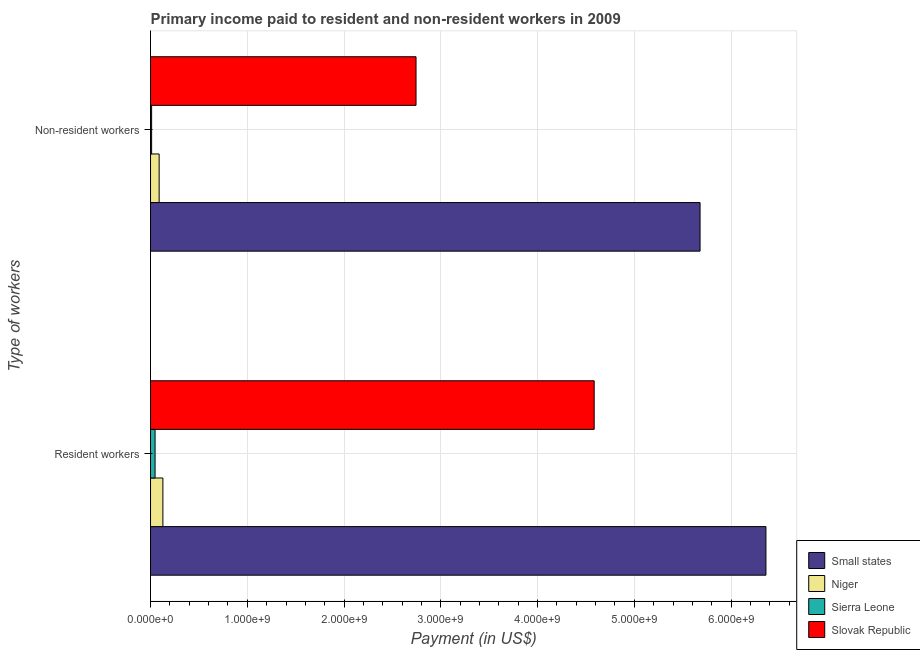Are the number of bars per tick equal to the number of legend labels?
Your answer should be compact. Yes. What is the label of the 1st group of bars from the top?
Keep it short and to the point. Non-resident workers. What is the payment made to resident workers in Slovak Republic?
Your answer should be compact. 4.59e+09. Across all countries, what is the maximum payment made to non-resident workers?
Provide a succinct answer. 5.68e+09. Across all countries, what is the minimum payment made to non-resident workers?
Your answer should be very brief. 1.13e+07. In which country was the payment made to resident workers maximum?
Provide a short and direct response. Small states. In which country was the payment made to resident workers minimum?
Provide a succinct answer. Sierra Leone. What is the total payment made to non-resident workers in the graph?
Offer a very short reply. 8.52e+09. What is the difference between the payment made to non-resident workers in Slovak Republic and that in Niger?
Ensure brevity in your answer.  2.65e+09. What is the difference between the payment made to resident workers in Niger and the payment made to non-resident workers in Small states?
Give a very brief answer. -5.55e+09. What is the average payment made to resident workers per country?
Provide a succinct answer. 2.78e+09. What is the difference between the payment made to resident workers and payment made to non-resident workers in Niger?
Your answer should be compact. 3.88e+07. What is the ratio of the payment made to non-resident workers in Niger to that in Slovak Republic?
Offer a terse response. 0.03. In how many countries, is the payment made to resident workers greater than the average payment made to resident workers taken over all countries?
Provide a short and direct response. 2. What does the 3rd bar from the top in Resident workers represents?
Your answer should be compact. Niger. What does the 3rd bar from the bottom in Resident workers represents?
Give a very brief answer. Sierra Leone. How many bars are there?
Give a very brief answer. 8. How many countries are there in the graph?
Your answer should be compact. 4. What is the difference between two consecutive major ticks on the X-axis?
Give a very brief answer. 1.00e+09. Does the graph contain any zero values?
Keep it short and to the point. No. How many legend labels are there?
Ensure brevity in your answer.  4. How are the legend labels stacked?
Keep it short and to the point. Vertical. What is the title of the graph?
Your answer should be compact. Primary income paid to resident and non-resident workers in 2009. Does "Lower middle income" appear as one of the legend labels in the graph?
Keep it short and to the point. No. What is the label or title of the X-axis?
Provide a short and direct response. Payment (in US$). What is the label or title of the Y-axis?
Offer a terse response. Type of workers. What is the Payment (in US$) in Small states in Resident workers?
Make the answer very short. 6.36e+09. What is the Payment (in US$) of Niger in Resident workers?
Offer a terse response. 1.28e+08. What is the Payment (in US$) of Sierra Leone in Resident workers?
Make the answer very short. 4.69e+07. What is the Payment (in US$) in Slovak Republic in Resident workers?
Make the answer very short. 4.59e+09. What is the Payment (in US$) of Small states in Non-resident workers?
Your response must be concise. 5.68e+09. What is the Payment (in US$) of Niger in Non-resident workers?
Make the answer very short. 8.89e+07. What is the Payment (in US$) in Sierra Leone in Non-resident workers?
Ensure brevity in your answer.  1.13e+07. What is the Payment (in US$) of Slovak Republic in Non-resident workers?
Keep it short and to the point. 2.74e+09. Across all Type of workers, what is the maximum Payment (in US$) of Small states?
Keep it short and to the point. 6.36e+09. Across all Type of workers, what is the maximum Payment (in US$) in Niger?
Your response must be concise. 1.28e+08. Across all Type of workers, what is the maximum Payment (in US$) of Sierra Leone?
Your response must be concise. 4.69e+07. Across all Type of workers, what is the maximum Payment (in US$) in Slovak Republic?
Your response must be concise. 4.59e+09. Across all Type of workers, what is the minimum Payment (in US$) in Small states?
Provide a short and direct response. 5.68e+09. Across all Type of workers, what is the minimum Payment (in US$) in Niger?
Make the answer very short. 8.89e+07. Across all Type of workers, what is the minimum Payment (in US$) in Sierra Leone?
Your response must be concise. 1.13e+07. Across all Type of workers, what is the minimum Payment (in US$) in Slovak Republic?
Your response must be concise. 2.74e+09. What is the total Payment (in US$) in Small states in the graph?
Your answer should be very brief. 1.20e+1. What is the total Payment (in US$) in Niger in the graph?
Provide a succinct answer. 2.17e+08. What is the total Payment (in US$) in Sierra Leone in the graph?
Provide a short and direct response. 5.82e+07. What is the total Payment (in US$) in Slovak Republic in the graph?
Give a very brief answer. 7.33e+09. What is the difference between the Payment (in US$) of Small states in Resident workers and that in Non-resident workers?
Make the answer very short. 6.81e+08. What is the difference between the Payment (in US$) in Niger in Resident workers and that in Non-resident workers?
Ensure brevity in your answer.  3.88e+07. What is the difference between the Payment (in US$) in Sierra Leone in Resident workers and that in Non-resident workers?
Your answer should be very brief. 3.57e+07. What is the difference between the Payment (in US$) of Slovak Republic in Resident workers and that in Non-resident workers?
Provide a succinct answer. 1.84e+09. What is the difference between the Payment (in US$) of Small states in Resident workers and the Payment (in US$) of Niger in Non-resident workers?
Provide a succinct answer. 6.27e+09. What is the difference between the Payment (in US$) of Small states in Resident workers and the Payment (in US$) of Sierra Leone in Non-resident workers?
Your response must be concise. 6.35e+09. What is the difference between the Payment (in US$) in Small states in Resident workers and the Payment (in US$) in Slovak Republic in Non-resident workers?
Your answer should be very brief. 3.62e+09. What is the difference between the Payment (in US$) in Niger in Resident workers and the Payment (in US$) in Sierra Leone in Non-resident workers?
Keep it short and to the point. 1.16e+08. What is the difference between the Payment (in US$) of Niger in Resident workers and the Payment (in US$) of Slovak Republic in Non-resident workers?
Make the answer very short. -2.62e+09. What is the difference between the Payment (in US$) in Sierra Leone in Resident workers and the Payment (in US$) in Slovak Republic in Non-resident workers?
Keep it short and to the point. -2.70e+09. What is the average Payment (in US$) in Small states per Type of workers?
Keep it short and to the point. 6.02e+09. What is the average Payment (in US$) in Niger per Type of workers?
Offer a very short reply. 1.08e+08. What is the average Payment (in US$) in Sierra Leone per Type of workers?
Offer a terse response. 2.91e+07. What is the average Payment (in US$) in Slovak Republic per Type of workers?
Offer a very short reply. 3.66e+09. What is the difference between the Payment (in US$) of Small states and Payment (in US$) of Niger in Resident workers?
Your answer should be compact. 6.23e+09. What is the difference between the Payment (in US$) in Small states and Payment (in US$) in Sierra Leone in Resident workers?
Offer a terse response. 6.31e+09. What is the difference between the Payment (in US$) in Small states and Payment (in US$) in Slovak Republic in Resident workers?
Your answer should be compact. 1.78e+09. What is the difference between the Payment (in US$) of Niger and Payment (in US$) of Sierra Leone in Resident workers?
Your response must be concise. 8.08e+07. What is the difference between the Payment (in US$) in Niger and Payment (in US$) in Slovak Republic in Resident workers?
Your answer should be very brief. -4.46e+09. What is the difference between the Payment (in US$) in Sierra Leone and Payment (in US$) in Slovak Republic in Resident workers?
Keep it short and to the point. -4.54e+09. What is the difference between the Payment (in US$) of Small states and Payment (in US$) of Niger in Non-resident workers?
Provide a short and direct response. 5.59e+09. What is the difference between the Payment (in US$) in Small states and Payment (in US$) in Sierra Leone in Non-resident workers?
Make the answer very short. 5.67e+09. What is the difference between the Payment (in US$) of Small states and Payment (in US$) of Slovak Republic in Non-resident workers?
Ensure brevity in your answer.  2.94e+09. What is the difference between the Payment (in US$) in Niger and Payment (in US$) in Sierra Leone in Non-resident workers?
Make the answer very short. 7.77e+07. What is the difference between the Payment (in US$) of Niger and Payment (in US$) of Slovak Republic in Non-resident workers?
Make the answer very short. -2.65e+09. What is the difference between the Payment (in US$) in Sierra Leone and Payment (in US$) in Slovak Republic in Non-resident workers?
Your answer should be compact. -2.73e+09. What is the ratio of the Payment (in US$) of Small states in Resident workers to that in Non-resident workers?
Your answer should be compact. 1.12. What is the ratio of the Payment (in US$) in Niger in Resident workers to that in Non-resident workers?
Keep it short and to the point. 1.44. What is the ratio of the Payment (in US$) of Sierra Leone in Resident workers to that in Non-resident workers?
Your answer should be very brief. 4.17. What is the ratio of the Payment (in US$) in Slovak Republic in Resident workers to that in Non-resident workers?
Ensure brevity in your answer.  1.67. What is the difference between the highest and the second highest Payment (in US$) in Small states?
Keep it short and to the point. 6.81e+08. What is the difference between the highest and the second highest Payment (in US$) of Niger?
Provide a short and direct response. 3.88e+07. What is the difference between the highest and the second highest Payment (in US$) of Sierra Leone?
Provide a short and direct response. 3.57e+07. What is the difference between the highest and the second highest Payment (in US$) in Slovak Republic?
Offer a very short reply. 1.84e+09. What is the difference between the highest and the lowest Payment (in US$) in Small states?
Offer a very short reply. 6.81e+08. What is the difference between the highest and the lowest Payment (in US$) of Niger?
Provide a short and direct response. 3.88e+07. What is the difference between the highest and the lowest Payment (in US$) of Sierra Leone?
Your answer should be very brief. 3.57e+07. What is the difference between the highest and the lowest Payment (in US$) of Slovak Republic?
Provide a succinct answer. 1.84e+09. 